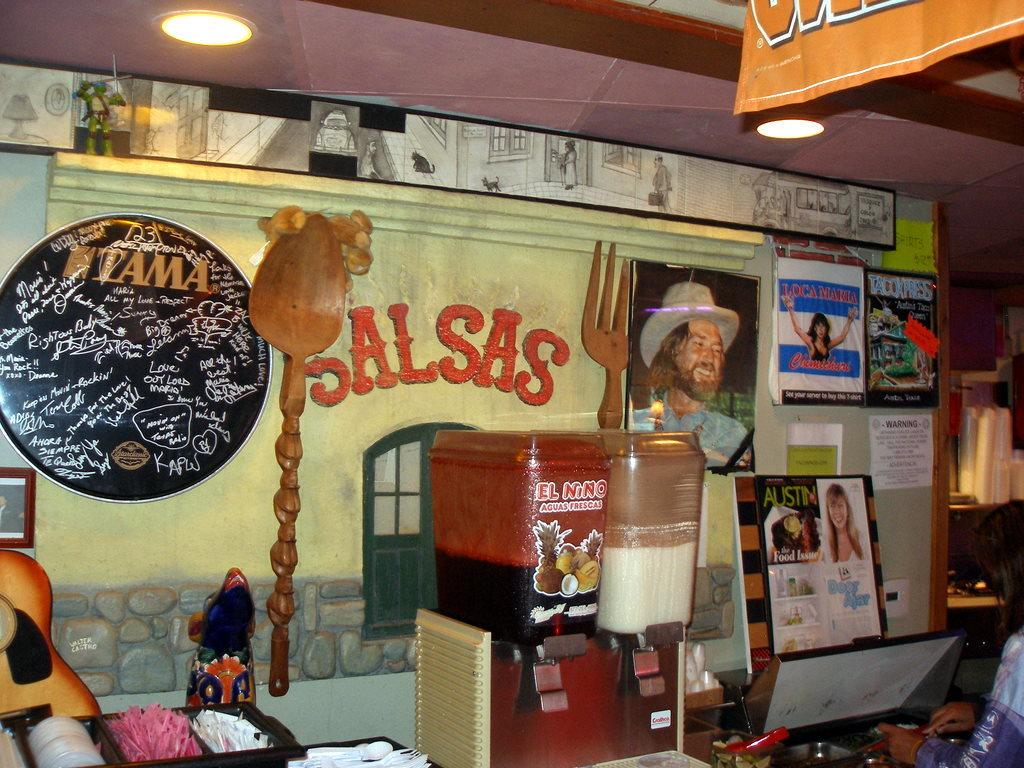What is the main object in the middle of the image? There is a juicer in the middle of the image. What can be seen on the right side of the image? There are photographs on the right side of the image. Where is the light located in the image? The light is at the top left corner of the image. Can you see any snakes in the image? There are no snakes present in the image. What type of pleasure can be experienced from the juicer in the image? The image does not convey any information about the pleasure that might be experienced from the juicer; it only shows the juicer itself. 